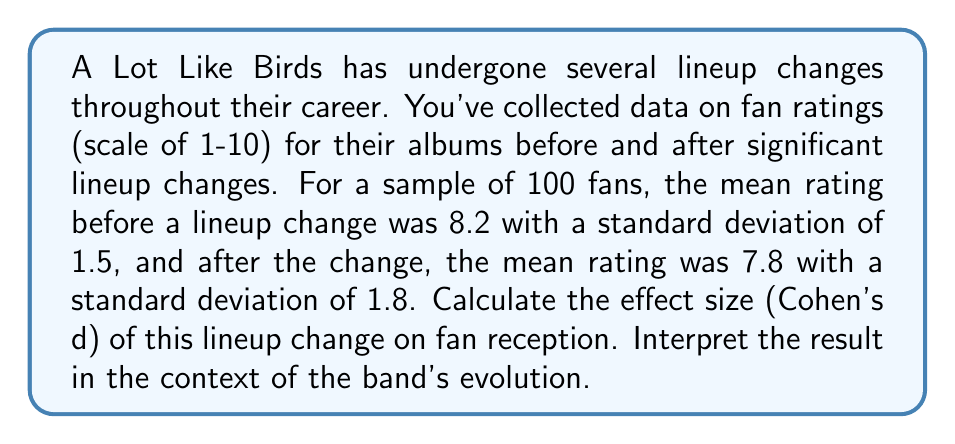Solve this math problem. To analyze the statistical correlation between lineup changes and fan reception, we'll calculate Cohen's d, which measures the standardized difference between two means. The steps are as follows:

1. Identify the means and standard deviations:
   Before change: $\mu_1 = 8.2$, $\sigma_1 = 1.5$
   After change: $\mu_2 = 7.8$, $\sigma_2 = 1.8$

2. Calculate the pooled standard deviation:
   $$s_p = \sqrt{\frac{(n_1 - 1)s_1^2 + (n_2 - 1)s_2^2}{n_1 + n_2 - 2}}$$
   Where $n_1 = n_2 = 100$ (sample size for each group)
   
   $$s_p = \sqrt{\frac{(100 - 1)(1.5)^2 + (100 - 1)(1.8)^2}{100 + 100 - 2}}$$
   $$s_p = \sqrt{\frac{99(2.25) + 99(3.24)}{198}} = \sqrt{\frac{222.75 + 320.76}{198}} = \sqrt{2.745} \approx 1.657$$

3. Calculate Cohen's d:
   $$d = \frac{\mu_1 - \mu_2}{s_p} = \frac{8.2 - 7.8}{1.657} \approx 0.241$$

4. Interpret the result:
   - Cohen's d of 0.2 is considered a small effect
   - Cohen's d of 0.5 is considered a medium effect
   - Cohen's d of 0.8 is considered a large effect

The calculated Cohen's d of 0.241 indicates a small to medium effect size. This suggests that the lineup change had a noticeable but not dramatic impact on fan reception. The slight decrease in mean rating (from 8.2 to 7.8) and the small effect size align with the mixed feelings fans might have about the band's evolution and musical shifts following lineup changes.
Answer: Cohen's d ≈ 0.241 (small to medium effect) 